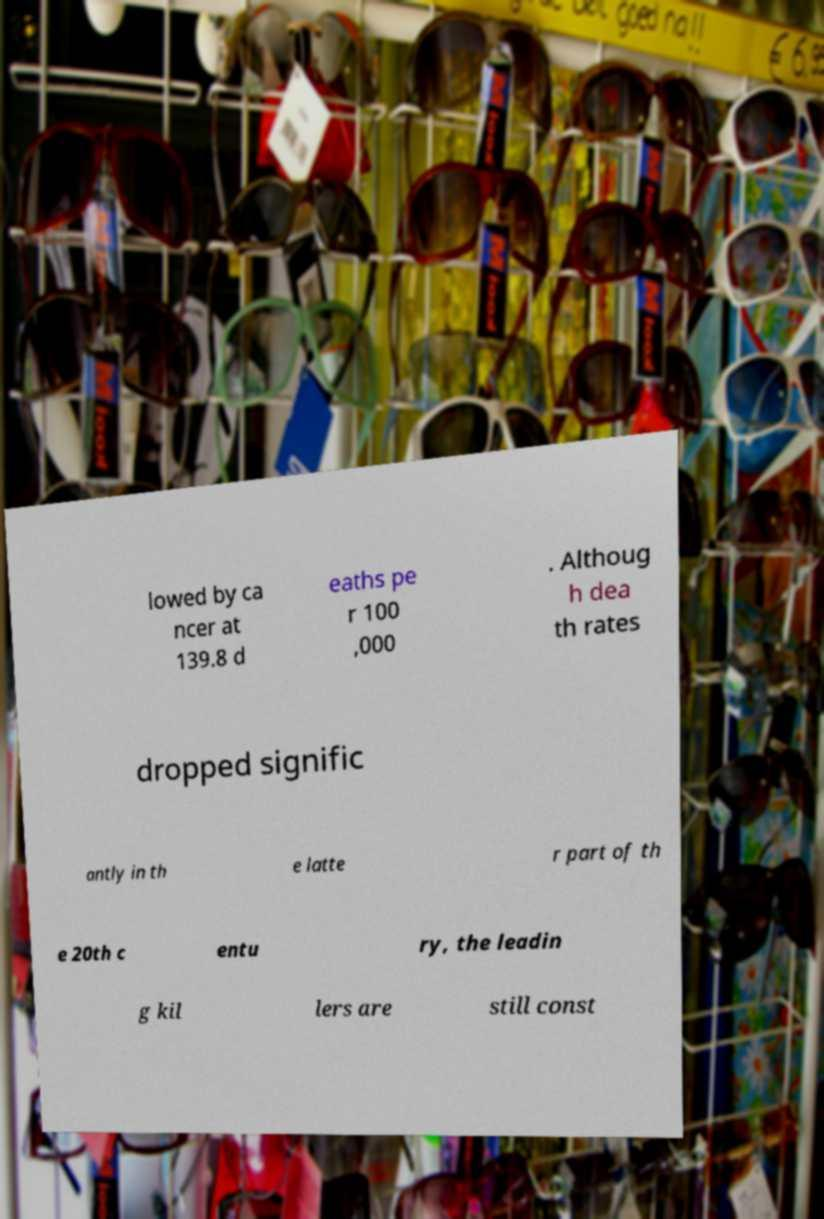Can you accurately transcribe the text from the provided image for me? lowed by ca ncer at 139.8 d eaths pe r 100 ,000 . Althoug h dea th rates dropped signific antly in th e latte r part of th e 20th c entu ry, the leadin g kil lers are still const 